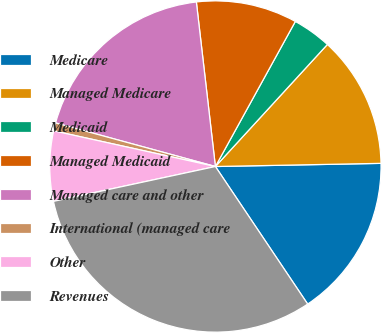<chart> <loc_0><loc_0><loc_500><loc_500><pie_chart><fcel>Medicare<fcel>Managed Medicare<fcel>Medicaid<fcel>Managed Medicaid<fcel>Managed care and other<fcel>International (managed care<fcel>Other<fcel>Revenues<nl><fcel>15.9%<fcel>12.88%<fcel>3.8%<fcel>9.85%<fcel>18.93%<fcel>0.78%<fcel>6.83%<fcel>31.03%<nl></chart> 